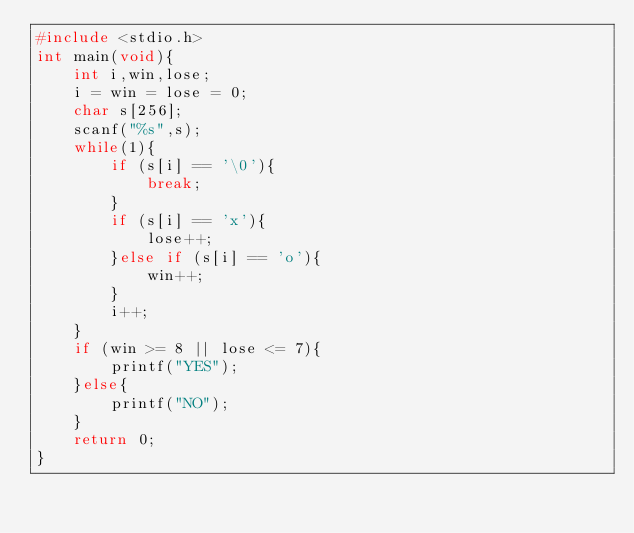<code> <loc_0><loc_0><loc_500><loc_500><_C_>#include <stdio.h>
int main(void){
    int i,win,lose;
    i = win = lose = 0;
    char s[256];
    scanf("%s",s);
    while(1){
        if (s[i] == '\0'){
            break;
        }
        if (s[i] == 'x'){
            lose++;
        }else if (s[i] == 'o'){
            win++;
        }
        i++;
    }
    if (win >= 8 || lose <= 7){
        printf("YES");
    }else{
        printf("NO");
    }
    return 0;
}</code> 